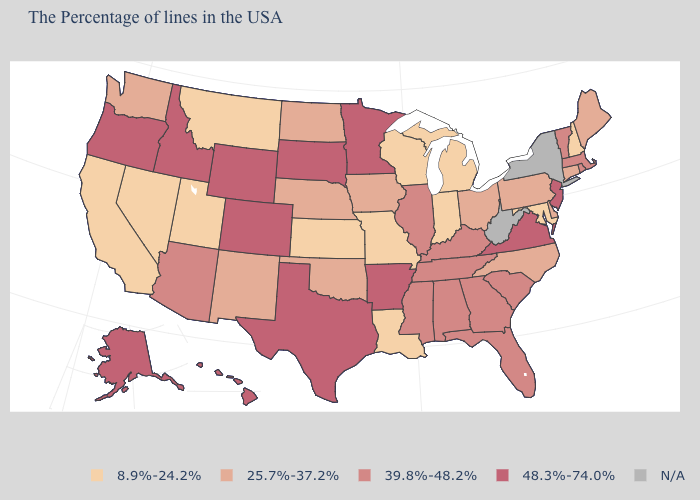What is the value of Vermont?
Answer briefly. 39.8%-48.2%. What is the value of West Virginia?
Answer briefly. N/A. What is the value of Utah?
Short answer required. 8.9%-24.2%. Among the states that border Massachusetts , which have the highest value?
Be succinct. Rhode Island, Vermont. Name the states that have a value in the range 25.7%-37.2%?
Concise answer only. Maine, Connecticut, Delaware, Pennsylvania, North Carolina, Ohio, Iowa, Nebraska, Oklahoma, North Dakota, New Mexico, Washington. Name the states that have a value in the range 25.7%-37.2%?
Write a very short answer. Maine, Connecticut, Delaware, Pennsylvania, North Carolina, Ohio, Iowa, Nebraska, Oklahoma, North Dakota, New Mexico, Washington. What is the value of Louisiana?
Keep it brief. 8.9%-24.2%. Name the states that have a value in the range 48.3%-74.0%?
Write a very short answer. New Jersey, Virginia, Arkansas, Minnesota, Texas, South Dakota, Wyoming, Colorado, Idaho, Oregon, Alaska, Hawaii. What is the lowest value in the West?
Keep it brief. 8.9%-24.2%. Among the states that border South Carolina , which have the lowest value?
Answer briefly. North Carolina. 